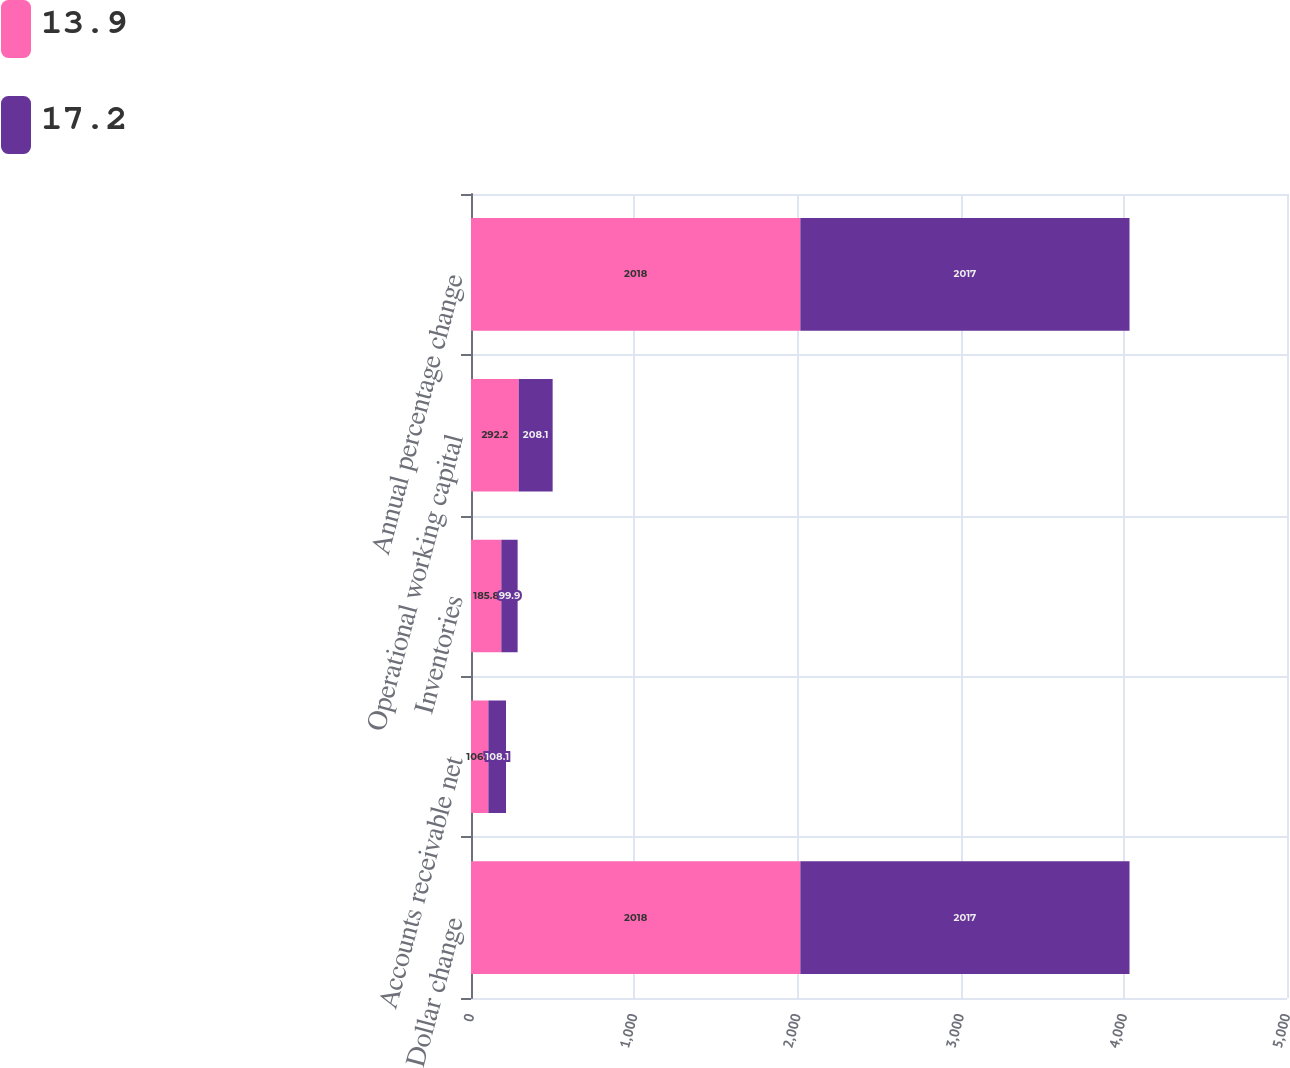Convert chart to OTSL. <chart><loc_0><loc_0><loc_500><loc_500><stacked_bar_chart><ecel><fcel>Dollar change<fcel>Accounts receivable net<fcel>Inventories<fcel>Operational working capital<fcel>Annual percentage change<nl><fcel>13.9<fcel>2018<fcel>106.4<fcel>185.8<fcel>292.2<fcel>2018<nl><fcel>17.2<fcel>2017<fcel>108.1<fcel>99.9<fcel>208.1<fcel>2017<nl></chart> 